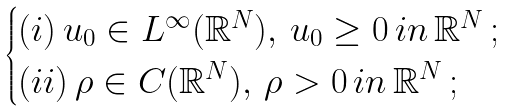Convert formula to latex. <formula><loc_0><loc_0><loc_500><loc_500>\begin{cases} ( i ) \, u _ { 0 } \in L ^ { \infty } ( \mathbb { R } ^ { N } ) , \, u _ { 0 } \geq 0 \, i n \, \mathbb { R } ^ { N } \, ; \\ ( i i ) \, \rho \in C ( \mathbb { R } ^ { N } ) , \, \rho > 0 \, i n \, \mathbb { R } ^ { N } \, ; \end{cases}</formula> 